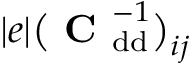Convert formula to latex. <formula><loc_0><loc_0><loc_500><loc_500>| e | \left ( C _ { d d } ^ { - 1 } \right ) _ { i j }</formula> 